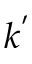<formula> <loc_0><loc_0><loc_500><loc_500>k ^ { ^ { \prime } }</formula> 